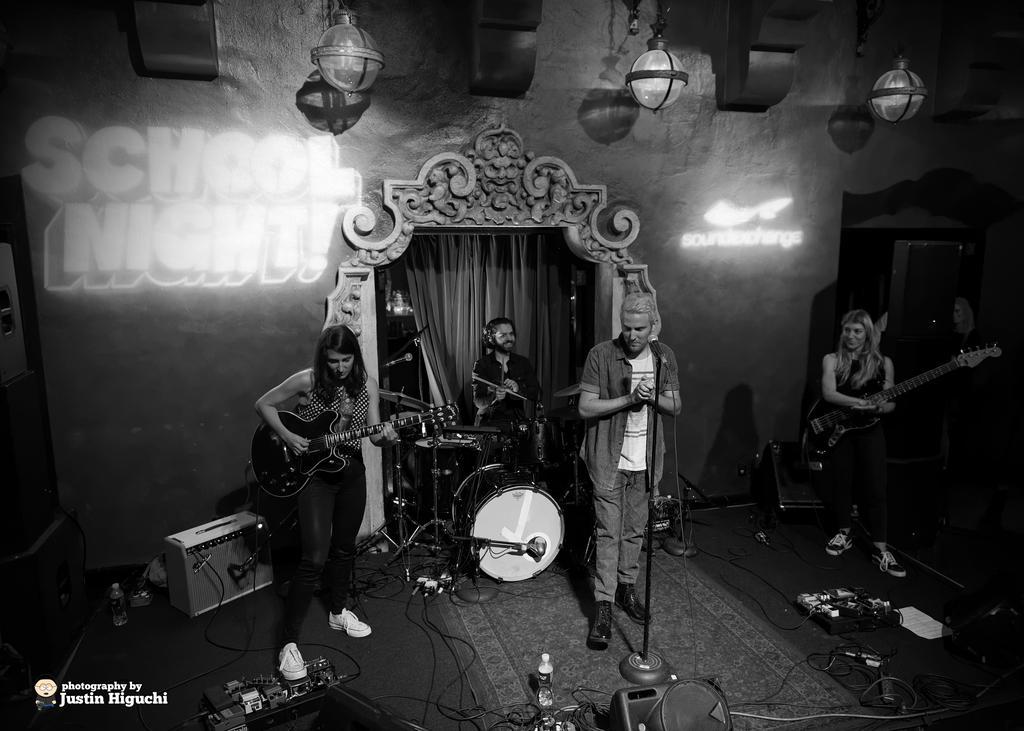Can you describe this image briefly? This is a black and white picture. In this picture we can see there is some projection of letters on the wall. We can see a curtain and people playing musical instruments. We can see a man standing a near to a mike. On the floor we can see bottles, electronic devices and wires. At the top we can see lights. In the bottom left corner there is a watermark. 